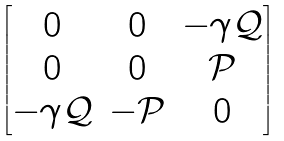Convert formula to latex. <formula><loc_0><loc_0><loc_500><loc_500>\begin{bmatrix} 0 & 0 & - \gamma \mathcal { Q } \\ 0 & 0 & \mathcal { P } \\ - \gamma \mathcal { Q } & - \mathcal { P } & 0 \end{bmatrix}</formula> 